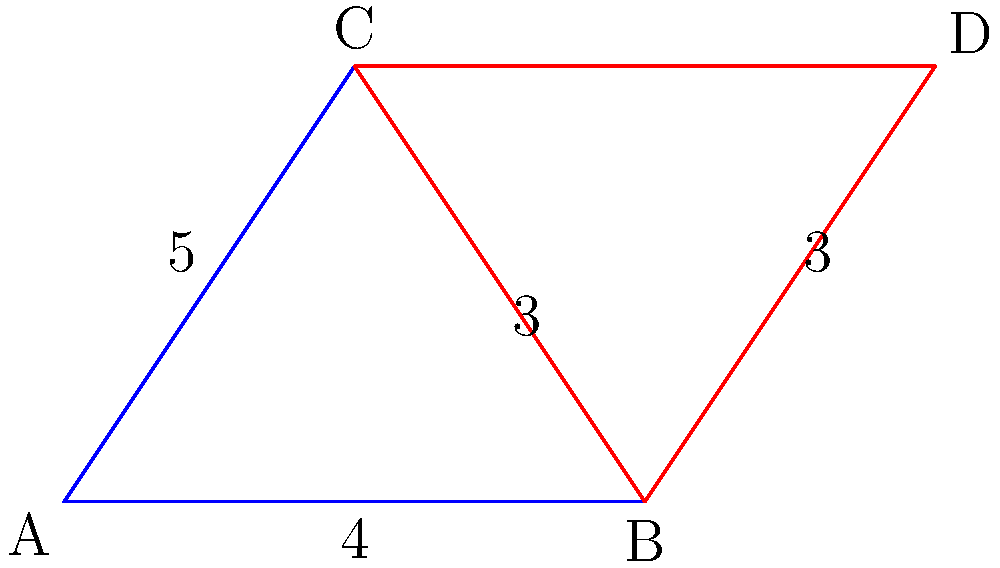In a new Broadway choreography, you're designing a formation where two groups of dancers form congruent triangles. The blue triangle represents the first group, and the red triangle represents the second group. Given that AB = 4 units, BC = 3 units, and AC = 5 units, what is the length of BD? Let's approach this step-by-step:

1) First, we need to recognize that triangles ABC and BCD are congruent. This is given in the problem statement and is key to solving the question.

2) In triangle ABC, we're given:
   AB = 4 units
   BC = 3 units
   AC = 5 units

3) Since the triangles are congruent, corresponding sides will be equal. Therefore, in triangle BCD:
   BC = 3 units (given)
   CD = AB = 4 units
   BD = AC = 5 units

4) The question asks for the length of BD, which we've determined is equal to AC.

5) Therefore, BD = 5 units.

This problem demonstrates how congruence can be used in choreography to create symmetrical formations, a common technique in Broadway performances.
Answer: 5 units 